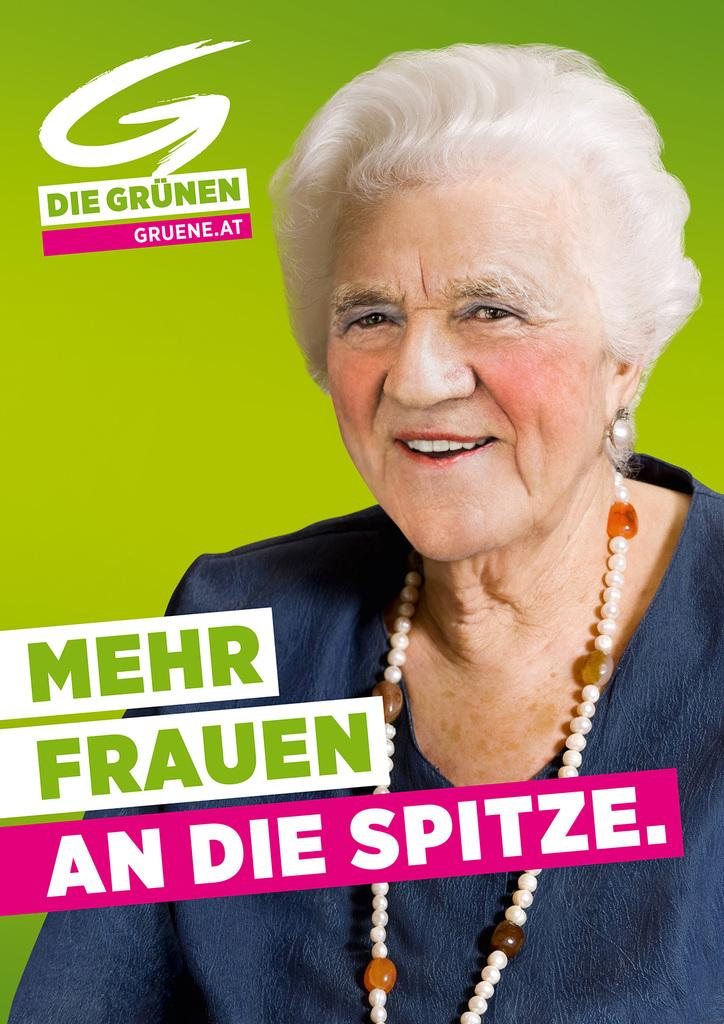Who is present in the image? There is a woman in the image. What is the woman's facial expression? The woman is smiling. What else can be seen in the image besides the woman? There is text visible in the image. Is the woman's servant involved in a fight with her elbow in the image? There is no servant, fight, or elbow present in the image. 